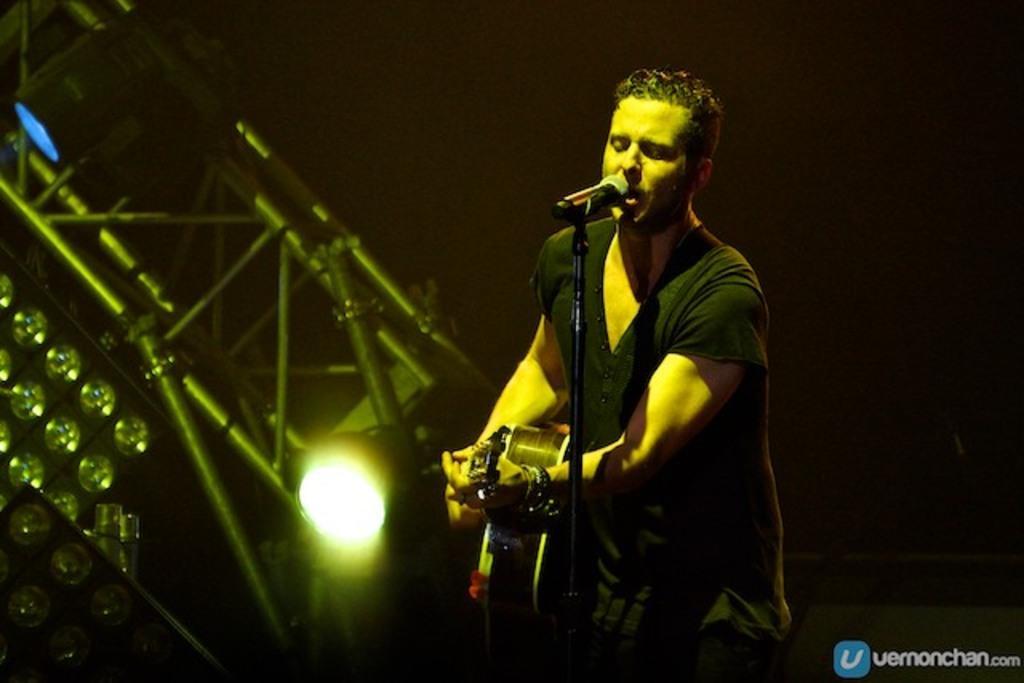Please provide a concise description of this image. As we can see in the image there are lights and a man standing and holding guitar and this person is singing song on mic. 